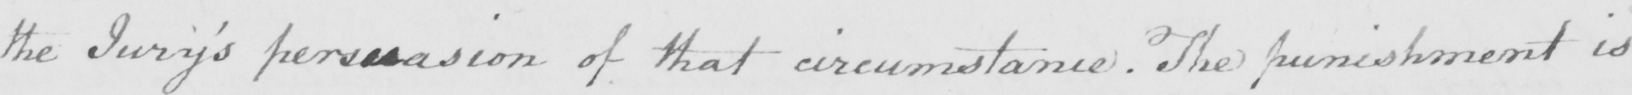What does this handwritten line say? the Jury ' s persuasion of that circumstance . The punishment is 